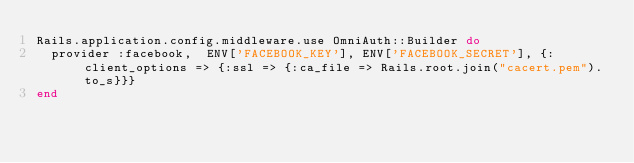<code> <loc_0><loc_0><loc_500><loc_500><_Ruby_>Rails.application.config.middleware.use OmniAuth::Builder do
  provider :facebook,  ENV['FACEBOOK_KEY'], ENV['FACEBOOK_SECRET'], {:client_options => {:ssl => {:ca_file => Rails.root.join("cacert.pem").to_s}}}
end</code> 